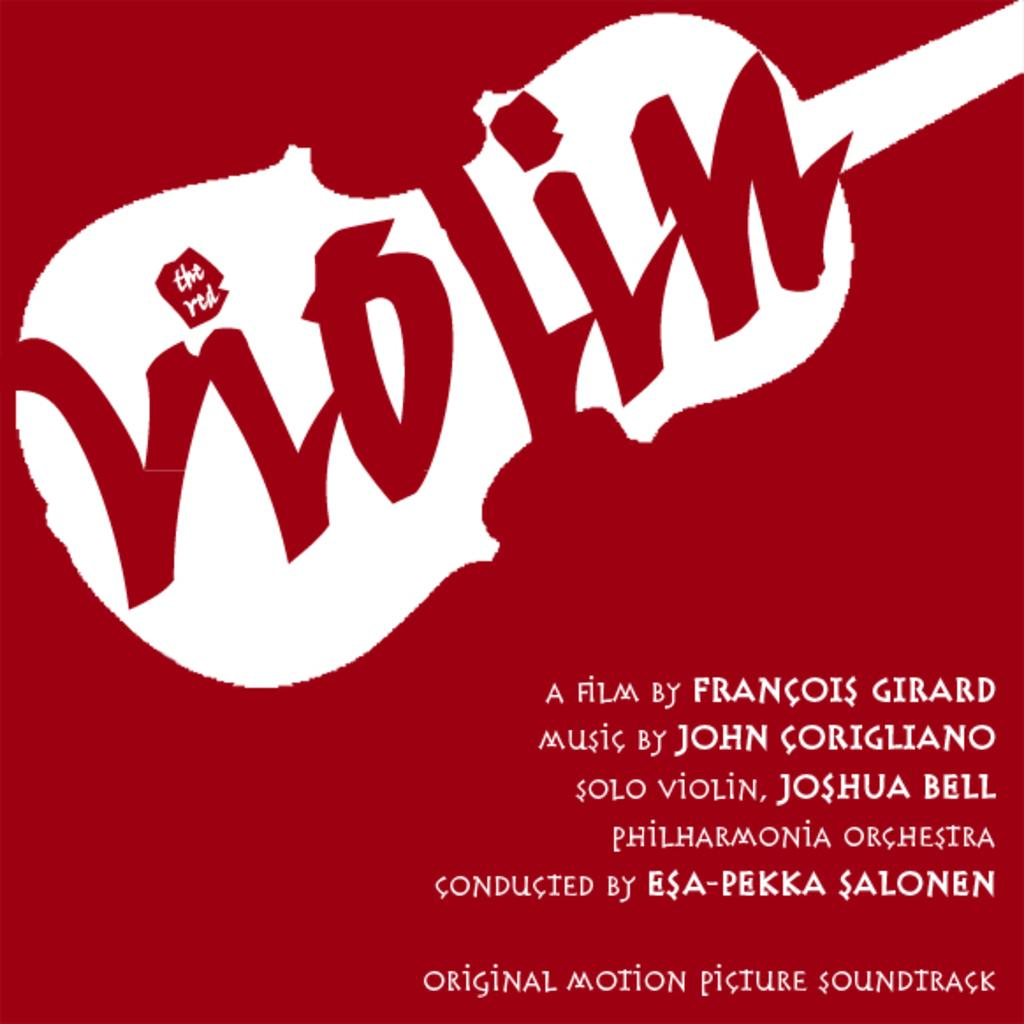<image>
Write a terse but informative summary of the picture. An advertisement for the soundtrack to The Red Violin. 